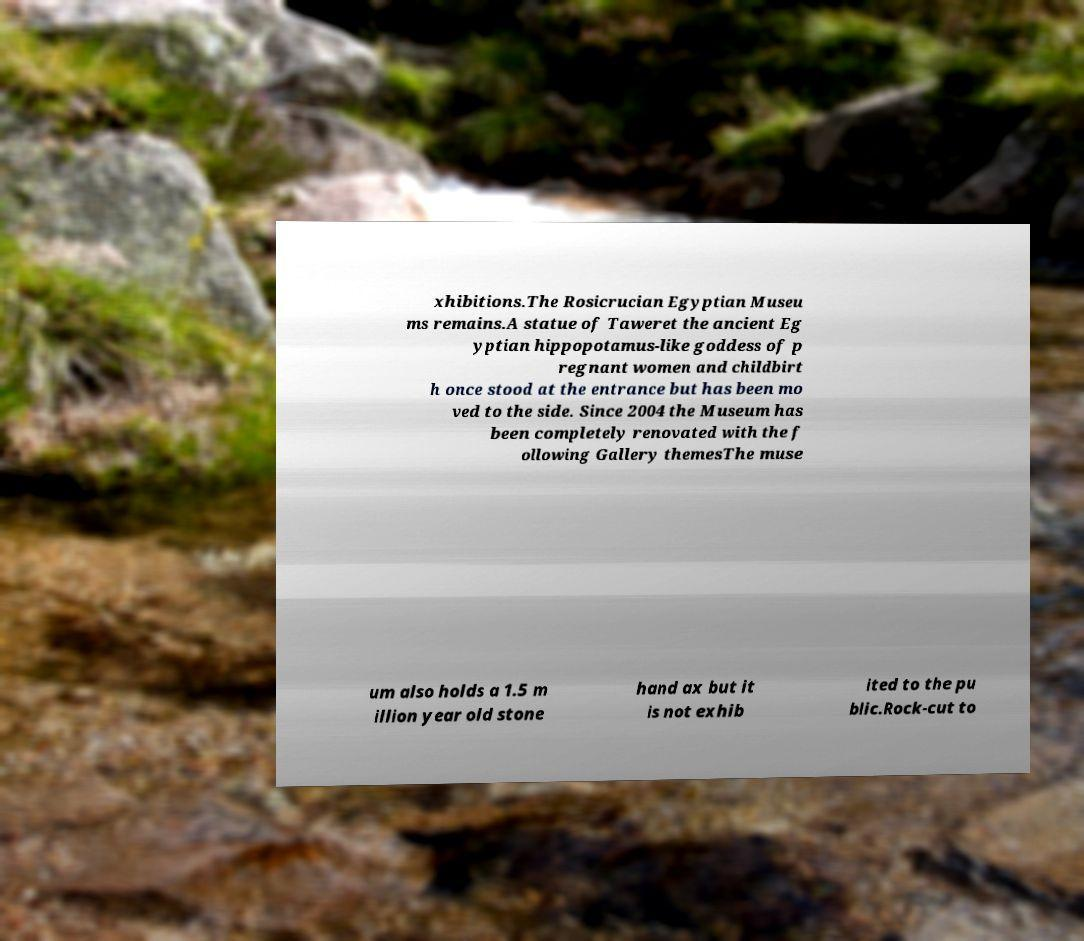There's text embedded in this image that I need extracted. Can you transcribe it verbatim? xhibitions.The Rosicrucian Egyptian Museu ms remains.A statue of Taweret the ancient Eg yptian hippopotamus-like goddess of p regnant women and childbirt h once stood at the entrance but has been mo ved to the side. Since 2004 the Museum has been completely renovated with the f ollowing Gallery themesThe muse um also holds a 1.5 m illion year old stone hand ax but it is not exhib ited to the pu blic.Rock-cut to 